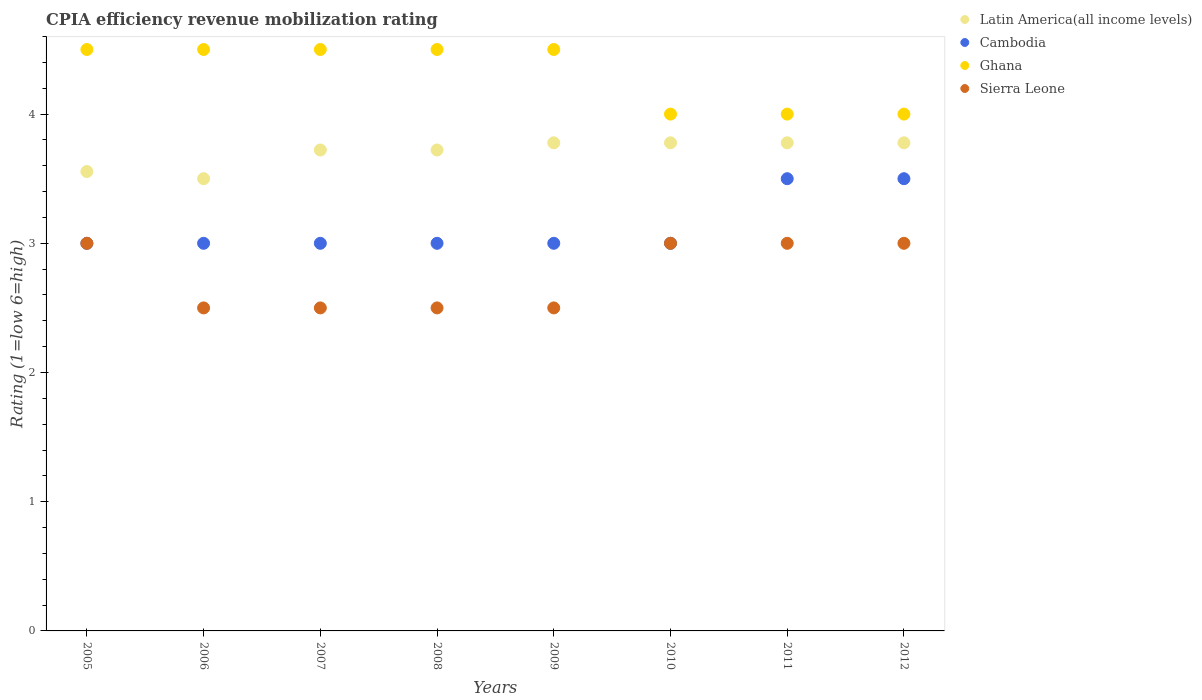Across all years, what is the minimum CPIA rating in Latin America(all income levels)?
Give a very brief answer. 3.5. What is the total CPIA rating in Latin America(all income levels) in the graph?
Offer a very short reply. 29.61. What is the difference between the CPIA rating in Latin America(all income levels) in 2005 and that in 2011?
Provide a short and direct response. -0.22. What is the difference between the CPIA rating in Latin America(all income levels) in 2009 and the CPIA rating in Ghana in 2010?
Offer a terse response. -0.22. What is the average CPIA rating in Latin America(all income levels) per year?
Provide a short and direct response. 3.7. In the year 2005, what is the difference between the CPIA rating in Ghana and CPIA rating in Latin America(all income levels)?
Your answer should be very brief. 0.94. What is the ratio of the CPIA rating in Cambodia in 2006 to that in 2012?
Provide a succinct answer. 0.86. Is the CPIA rating in Sierra Leone in 2007 less than that in 2009?
Offer a very short reply. No. What is the difference between the highest and the second highest CPIA rating in Cambodia?
Your response must be concise. 0. What is the difference between the highest and the lowest CPIA rating in Latin America(all income levels)?
Ensure brevity in your answer.  0.28. In how many years, is the CPIA rating in Ghana greater than the average CPIA rating in Ghana taken over all years?
Your answer should be compact. 5. Is it the case that in every year, the sum of the CPIA rating in Ghana and CPIA rating in Cambodia  is greater than the sum of CPIA rating in Latin America(all income levels) and CPIA rating in Sierra Leone?
Provide a succinct answer. No. Does the CPIA rating in Latin America(all income levels) monotonically increase over the years?
Your response must be concise. No. Is the CPIA rating in Cambodia strictly greater than the CPIA rating in Latin America(all income levels) over the years?
Make the answer very short. No. Is the CPIA rating in Ghana strictly less than the CPIA rating in Sierra Leone over the years?
Keep it short and to the point. No. How many years are there in the graph?
Your response must be concise. 8. Where does the legend appear in the graph?
Ensure brevity in your answer.  Top right. What is the title of the graph?
Provide a short and direct response. CPIA efficiency revenue mobilization rating. What is the label or title of the Y-axis?
Make the answer very short. Rating (1=low 6=high). What is the Rating (1=low 6=high) in Latin America(all income levels) in 2005?
Provide a short and direct response. 3.56. What is the Rating (1=low 6=high) in Ghana in 2006?
Offer a very short reply. 4.5. What is the Rating (1=low 6=high) of Sierra Leone in 2006?
Your answer should be very brief. 2.5. What is the Rating (1=low 6=high) of Latin America(all income levels) in 2007?
Offer a very short reply. 3.72. What is the Rating (1=low 6=high) of Cambodia in 2007?
Your response must be concise. 3. What is the Rating (1=low 6=high) of Ghana in 2007?
Give a very brief answer. 4.5. What is the Rating (1=low 6=high) of Latin America(all income levels) in 2008?
Make the answer very short. 3.72. What is the Rating (1=low 6=high) of Cambodia in 2008?
Offer a very short reply. 3. What is the Rating (1=low 6=high) in Ghana in 2008?
Your answer should be very brief. 4.5. What is the Rating (1=low 6=high) in Sierra Leone in 2008?
Your response must be concise. 2.5. What is the Rating (1=low 6=high) of Latin America(all income levels) in 2009?
Your answer should be very brief. 3.78. What is the Rating (1=low 6=high) in Latin America(all income levels) in 2010?
Make the answer very short. 3.78. What is the Rating (1=low 6=high) in Cambodia in 2010?
Give a very brief answer. 3. What is the Rating (1=low 6=high) in Latin America(all income levels) in 2011?
Make the answer very short. 3.78. What is the Rating (1=low 6=high) in Latin America(all income levels) in 2012?
Offer a terse response. 3.78. What is the Rating (1=low 6=high) of Cambodia in 2012?
Give a very brief answer. 3.5. What is the Rating (1=low 6=high) of Sierra Leone in 2012?
Give a very brief answer. 3. Across all years, what is the maximum Rating (1=low 6=high) of Latin America(all income levels)?
Provide a succinct answer. 3.78. Across all years, what is the maximum Rating (1=low 6=high) in Sierra Leone?
Give a very brief answer. 3. Across all years, what is the minimum Rating (1=low 6=high) in Cambodia?
Give a very brief answer. 3. Across all years, what is the minimum Rating (1=low 6=high) in Ghana?
Offer a terse response. 4. What is the total Rating (1=low 6=high) in Latin America(all income levels) in the graph?
Provide a short and direct response. 29.61. What is the total Rating (1=low 6=high) of Ghana in the graph?
Make the answer very short. 34.5. What is the difference between the Rating (1=low 6=high) of Latin America(all income levels) in 2005 and that in 2006?
Your answer should be compact. 0.06. What is the difference between the Rating (1=low 6=high) in Cambodia in 2005 and that in 2006?
Provide a short and direct response. 0. What is the difference between the Rating (1=low 6=high) of Ghana in 2005 and that in 2006?
Offer a terse response. 0. What is the difference between the Rating (1=low 6=high) of Sierra Leone in 2005 and that in 2006?
Provide a short and direct response. 0.5. What is the difference between the Rating (1=low 6=high) in Latin America(all income levels) in 2005 and that in 2007?
Your answer should be very brief. -0.17. What is the difference between the Rating (1=low 6=high) of Cambodia in 2005 and that in 2007?
Provide a short and direct response. 0. What is the difference between the Rating (1=low 6=high) of Latin America(all income levels) in 2005 and that in 2008?
Your answer should be compact. -0.17. What is the difference between the Rating (1=low 6=high) in Ghana in 2005 and that in 2008?
Your response must be concise. 0. What is the difference between the Rating (1=low 6=high) in Latin America(all income levels) in 2005 and that in 2009?
Your response must be concise. -0.22. What is the difference between the Rating (1=low 6=high) in Ghana in 2005 and that in 2009?
Provide a succinct answer. 0. What is the difference between the Rating (1=low 6=high) in Sierra Leone in 2005 and that in 2009?
Your response must be concise. 0.5. What is the difference between the Rating (1=low 6=high) of Latin America(all income levels) in 2005 and that in 2010?
Your answer should be compact. -0.22. What is the difference between the Rating (1=low 6=high) of Cambodia in 2005 and that in 2010?
Provide a short and direct response. 0. What is the difference between the Rating (1=low 6=high) in Ghana in 2005 and that in 2010?
Offer a very short reply. 0.5. What is the difference between the Rating (1=low 6=high) in Latin America(all income levels) in 2005 and that in 2011?
Give a very brief answer. -0.22. What is the difference between the Rating (1=low 6=high) of Ghana in 2005 and that in 2011?
Provide a short and direct response. 0.5. What is the difference between the Rating (1=low 6=high) in Sierra Leone in 2005 and that in 2011?
Provide a short and direct response. 0. What is the difference between the Rating (1=low 6=high) in Latin America(all income levels) in 2005 and that in 2012?
Provide a short and direct response. -0.22. What is the difference between the Rating (1=low 6=high) of Cambodia in 2005 and that in 2012?
Make the answer very short. -0.5. What is the difference between the Rating (1=low 6=high) in Ghana in 2005 and that in 2012?
Your response must be concise. 0.5. What is the difference between the Rating (1=low 6=high) of Latin America(all income levels) in 2006 and that in 2007?
Provide a short and direct response. -0.22. What is the difference between the Rating (1=low 6=high) of Sierra Leone in 2006 and that in 2007?
Your answer should be compact. 0. What is the difference between the Rating (1=low 6=high) of Latin America(all income levels) in 2006 and that in 2008?
Ensure brevity in your answer.  -0.22. What is the difference between the Rating (1=low 6=high) of Ghana in 2006 and that in 2008?
Your response must be concise. 0. What is the difference between the Rating (1=low 6=high) in Sierra Leone in 2006 and that in 2008?
Your answer should be compact. 0. What is the difference between the Rating (1=low 6=high) in Latin America(all income levels) in 2006 and that in 2009?
Your answer should be very brief. -0.28. What is the difference between the Rating (1=low 6=high) in Cambodia in 2006 and that in 2009?
Offer a very short reply. 0. What is the difference between the Rating (1=low 6=high) in Sierra Leone in 2006 and that in 2009?
Your answer should be compact. 0. What is the difference between the Rating (1=low 6=high) of Latin America(all income levels) in 2006 and that in 2010?
Your answer should be very brief. -0.28. What is the difference between the Rating (1=low 6=high) in Cambodia in 2006 and that in 2010?
Provide a succinct answer. 0. What is the difference between the Rating (1=low 6=high) of Latin America(all income levels) in 2006 and that in 2011?
Your response must be concise. -0.28. What is the difference between the Rating (1=low 6=high) in Cambodia in 2006 and that in 2011?
Your answer should be very brief. -0.5. What is the difference between the Rating (1=low 6=high) of Ghana in 2006 and that in 2011?
Your answer should be compact. 0.5. What is the difference between the Rating (1=low 6=high) of Sierra Leone in 2006 and that in 2011?
Offer a terse response. -0.5. What is the difference between the Rating (1=low 6=high) of Latin America(all income levels) in 2006 and that in 2012?
Your answer should be very brief. -0.28. What is the difference between the Rating (1=low 6=high) in Cambodia in 2006 and that in 2012?
Give a very brief answer. -0.5. What is the difference between the Rating (1=low 6=high) in Ghana in 2006 and that in 2012?
Make the answer very short. 0.5. What is the difference between the Rating (1=low 6=high) of Latin America(all income levels) in 2007 and that in 2008?
Your answer should be very brief. 0. What is the difference between the Rating (1=low 6=high) in Cambodia in 2007 and that in 2008?
Offer a very short reply. 0. What is the difference between the Rating (1=low 6=high) in Sierra Leone in 2007 and that in 2008?
Make the answer very short. 0. What is the difference between the Rating (1=low 6=high) of Latin America(all income levels) in 2007 and that in 2009?
Make the answer very short. -0.06. What is the difference between the Rating (1=low 6=high) in Sierra Leone in 2007 and that in 2009?
Offer a very short reply. 0. What is the difference between the Rating (1=low 6=high) in Latin America(all income levels) in 2007 and that in 2010?
Offer a terse response. -0.06. What is the difference between the Rating (1=low 6=high) in Latin America(all income levels) in 2007 and that in 2011?
Provide a short and direct response. -0.06. What is the difference between the Rating (1=low 6=high) in Cambodia in 2007 and that in 2011?
Ensure brevity in your answer.  -0.5. What is the difference between the Rating (1=low 6=high) of Latin America(all income levels) in 2007 and that in 2012?
Ensure brevity in your answer.  -0.06. What is the difference between the Rating (1=low 6=high) of Cambodia in 2007 and that in 2012?
Ensure brevity in your answer.  -0.5. What is the difference between the Rating (1=low 6=high) of Latin America(all income levels) in 2008 and that in 2009?
Provide a short and direct response. -0.06. What is the difference between the Rating (1=low 6=high) of Cambodia in 2008 and that in 2009?
Offer a terse response. 0. What is the difference between the Rating (1=low 6=high) of Ghana in 2008 and that in 2009?
Your answer should be compact. 0. What is the difference between the Rating (1=low 6=high) of Sierra Leone in 2008 and that in 2009?
Your answer should be compact. 0. What is the difference between the Rating (1=low 6=high) in Latin America(all income levels) in 2008 and that in 2010?
Your response must be concise. -0.06. What is the difference between the Rating (1=low 6=high) in Latin America(all income levels) in 2008 and that in 2011?
Give a very brief answer. -0.06. What is the difference between the Rating (1=low 6=high) in Cambodia in 2008 and that in 2011?
Your answer should be very brief. -0.5. What is the difference between the Rating (1=low 6=high) in Sierra Leone in 2008 and that in 2011?
Your response must be concise. -0.5. What is the difference between the Rating (1=low 6=high) of Latin America(all income levels) in 2008 and that in 2012?
Keep it short and to the point. -0.06. What is the difference between the Rating (1=low 6=high) of Cambodia in 2009 and that in 2010?
Your answer should be compact. 0. What is the difference between the Rating (1=low 6=high) of Ghana in 2009 and that in 2010?
Your response must be concise. 0.5. What is the difference between the Rating (1=low 6=high) in Sierra Leone in 2009 and that in 2010?
Keep it short and to the point. -0.5. What is the difference between the Rating (1=low 6=high) of Ghana in 2009 and that in 2011?
Provide a short and direct response. 0.5. What is the difference between the Rating (1=low 6=high) in Latin America(all income levels) in 2009 and that in 2012?
Provide a succinct answer. 0. What is the difference between the Rating (1=low 6=high) in Ghana in 2009 and that in 2012?
Your answer should be very brief. 0.5. What is the difference between the Rating (1=low 6=high) of Sierra Leone in 2009 and that in 2012?
Offer a terse response. -0.5. What is the difference between the Rating (1=low 6=high) of Latin America(all income levels) in 2010 and that in 2011?
Ensure brevity in your answer.  0. What is the difference between the Rating (1=low 6=high) of Ghana in 2010 and that in 2011?
Provide a short and direct response. 0. What is the difference between the Rating (1=low 6=high) in Sierra Leone in 2010 and that in 2011?
Your answer should be very brief. 0. What is the difference between the Rating (1=low 6=high) in Cambodia in 2010 and that in 2012?
Keep it short and to the point. -0.5. What is the difference between the Rating (1=low 6=high) of Sierra Leone in 2010 and that in 2012?
Provide a succinct answer. 0. What is the difference between the Rating (1=low 6=high) in Latin America(all income levels) in 2011 and that in 2012?
Offer a terse response. 0. What is the difference between the Rating (1=low 6=high) of Cambodia in 2011 and that in 2012?
Your response must be concise. 0. What is the difference between the Rating (1=low 6=high) in Latin America(all income levels) in 2005 and the Rating (1=low 6=high) in Cambodia in 2006?
Your answer should be very brief. 0.56. What is the difference between the Rating (1=low 6=high) of Latin America(all income levels) in 2005 and the Rating (1=low 6=high) of Ghana in 2006?
Your answer should be compact. -0.94. What is the difference between the Rating (1=low 6=high) in Latin America(all income levels) in 2005 and the Rating (1=low 6=high) in Sierra Leone in 2006?
Keep it short and to the point. 1.06. What is the difference between the Rating (1=low 6=high) in Latin America(all income levels) in 2005 and the Rating (1=low 6=high) in Cambodia in 2007?
Provide a short and direct response. 0.56. What is the difference between the Rating (1=low 6=high) of Latin America(all income levels) in 2005 and the Rating (1=low 6=high) of Ghana in 2007?
Provide a succinct answer. -0.94. What is the difference between the Rating (1=low 6=high) in Latin America(all income levels) in 2005 and the Rating (1=low 6=high) in Sierra Leone in 2007?
Your answer should be compact. 1.06. What is the difference between the Rating (1=low 6=high) of Cambodia in 2005 and the Rating (1=low 6=high) of Ghana in 2007?
Ensure brevity in your answer.  -1.5. What is the difference between the Rating (1=low 6=high) of Ghana in 2005 and the Rating (1=low 6=high) of Sierra Leone in 2007?
Offer a terse response. 2. What is the difference between the Rating (1=low 6=high) in Latin America(all income levels) in 2005 and the Rating (1=low 6=high) in Cambodia in 2008?
Make the answer very short. 0.56. What is the difference between the Rating (1=low 6=high) in Latin America(all income levels) in 2005 and the Rating (1=low 6=high) in Ghana in 2008?
Keep it short and to the point. -0.94. What is the difference between the Rating (1=low 6=high) of Latin America(all income levels) in 2005 and the Rating (1=low 6=high) of Sierra Leone in 2008?
Your answer should be very brief. 1.06. What is the difference between the Rating (1=low 6=high) of Cambodia in 2005 and the Rating (1=low 6=high) of Ghana in 2008?
Your answer should be very brief. -1.5. What is the difference between the Rating (1=low 6=high) in Cambodia in 2005 and the Rating (1=low 6=high) in Sierra Leone in 2008?
Provide a short and direct response. 0.5. What is the difference between the Rating (1=low 6=high) in Latin America(all income levels) in 2005 and the Rating (1=low 6=high) in Cambodia in 2009?
Keep it short and to the point. 0.56. What is the difference between the Rating (1=low 6=high) of Latin America(all income levels) in 2005 and the Rating (1=low 6=high) of Ghana in 2009?
Offer a very short reply. -0.94. What is the difference between the Rating (1=low 6=high) in Latin America(all income levels) in 2005 and the Rating (1=low 6=high) in Sierra Leone in 2009?
Keep it short and to the point. 1.06. What is the difference between the Rating (1=low 6=high) of Cambodia in 2005 and the Rating (1=low 6=high) of Sierra Leone in 2009?
Provide a short and direct response. 0.5. What is the difference between the Rating (1=low 6=high) in Latin America(all income levels) in 2005 and the Rating (1=low 6=high) in Cambodia in 2010?
Ensure brevity in your answer.  0.56. What is the difference between the Rating (1=low 6=high) in Latin America(all income levels) in 2005 and the Rating (1=low 6=high) in Ghana in 2010?
Make the answer very short. -0.44. What is the difference between the Rating (1=low 6=high) of Latin America(all income levels) in 2005 and the Rating (1=low 6=high) of Sierra Leone in 2010?
Your response must be concise. 0.56. What is the difference between the Rating (1=low 6=high) in Cambodia in 2005 and the Rating (1=low 6=high) in Ghana in 2010?
Provide a succinct answer. -1. What is the difference between the Rating (1=low 6=high) of Cambodia in 2005 and the Rating (1=low 6=high) of Sierra Leone in 2010?
Offer a terse response. 0. What is the difference between the Rating (1=low 6=high) of Ghana in 2005 and the Rating (1=low 6=high) of Sierra Leone in 2010?
Provide a succinct answer. 1.5. What is the difference between the Rating (1=low 6=high) in Latin America(all income levels) in 2005 and the Rating (1=low 6=high) in Cambodia in 2011?
Keep it short and to the point. 0.06. What is the difference between the Rating (1=low 6=high) of Latin America(all income levels) in 2005 and the Rating (1=low 6=high) of Ghana in 2011?
Ensure brevity in your answer.  -0.44. What is the difference between the Rating (1=low 6=high) in Latin America(all income levels) in 2005 and the Rating (1=low 6=high) in Sierra Leone in 2011?
Keep it short and to the point. 0.56. What is the difference between the Rating (1=low 6=high) in Cambodia in 2005 and the Rating (1=low 6=high) in Ghana in 2011?
Your response must be concise. -1. What is the difference between the Rating (1=low 6=high) in Latin America(all income levels) in 2005 and the Rating (1=low 6=high) in Cambodia in 2012?
Your response must be concise. 0.06. What is the difference between the Rating (1=low 6=high) in Latin America(all income levels) in 2005 and the Rating (1=low 6=high) in Ghana in 2012?
Provide a succinct answer. -0.44. What is the difference between the Rating (1=low 6=high) in Latin America(all income levels) in 2005 and the Rating (1=low 6=high) in Sierra Leone in 2012?
Provide a succinct answer. 0.56. What is the difference between the Rating (1=low 6=high) in Cambodia in 2005 and the Rating (1=low 6=high) in Ghana in 2012?
Ensure brevity in your answer.  -1. What is the difference between the Rating (1=low 6=high) in Ghana in 2005 and the Rating (1=low 6=high) in Sierra Leone in 2012?
Provide a short and direct response. 1.5. What is the difference between the Rating (1=low 6=high) of Latin America(all income levels) in 2006 and the Rating (1=low 6=high) of Cambodia in 2007?
Keep it short and to the point. 0.5. What is the difference between the Rating (1=low 6=high) in Latin America(all income levels) in 2006 and the Rating (1=low 6=high) in Ghana in 2007?
Your answer should be compact. -1. What is the difference between the Rating (1=low 6=high) in Latin America(all income levels) in 2006 and the Rating (1=low 6=high) in Sierra Leone in 2007?
Offer a very short reply. 1. What is the difference between the Rating (1=low 6=high) in Cambodia in 2006 and the Rating (1=low 6=high) in Sierra Leone in 2007?
Offer a very short reply. 0.5. What is the difference between the Rating (1=low 6=high) in Latin America(all income levels) in 2006 and the Rating (1=low 6=high) in Ghana in 2008?
Your response must be concise. -1. What is the difference between the Rating (1=low 6=high) of Latin America(all income levels) in 2006 and the Rating (1=low 6=high) of Sierra Leone in 2008?
Your response must be concise. 1. What is the difference between the Rating (1=low 6=high) of Cambodia in 2006 and the Rating (1=low 6=high) of Ghana in 2008?
Ensure brevity in your answer.  -1.5. What is the difference between the Rating (1=low 6=high) of Ghana in 2006 and the Rating (1=low 6=high) of Sierra Leone in 2008?
Your answer should be very brief. 2. What is the difference between the Rating (1=low 6=high) in Latin America(all income levels) in 2006 and the Rating (1=low 6=high) in Sierra Leone in 2009?
Provide a succinct answer. 1. What is the difference between the Rating (1=low 6=high) of Cambodia in 2006 and the Rating (1=low 6=high) of Ghana in 2009?
Provide a short and direct response. -1.5. What is the difference between the Rating (1=low 6=high) of Cambodia in 2006 and the Rating (1=low 6=high) of Sierra Leone in 2009?
Provide a short and direct response. 0.5. What is the difference between the Rating (1=low 6=high) of Latin America(all income levels) in 2006 and the Rating (1=low 6=high) of Cambodia in 2010?
Give a very brief answer. 0.5. What is the difference between the Rating (1=low 6=high) in Latin America(all income levels) in 2006 and the Rating (1=low 6=high) in Sierra Leone in 2010?
Provide a succinct answer. 0.5. What is the difference between the Rating (1=low 6=high) of Cambodia in 2006 and the Rating (1=low 6=high) of Ghana in 2010?
Ensure brevity in your answer.  -1. What is the difference between the Rating (1=low 6=high) in Ghana in 2006 and the Rating (1=low 6=high) in Sierra Leone in 2010?
Offer a terse response. 1.5. What is the difference between the Rating (1=low 6=high) of Latin America(all income levels) in 2006 and the Rating (1=low 6=high) of Cambodia in 2011?
Offer a terse response. 0. What is the difference between the Rating (1=low 6=high) in Cambodia in 2006 and the Rating (1=low 6=high) in Sierra Leone in 2011?
Your response must be concise. 0. What is the difference between the Rating (1=low 6=high) in Latin America(all income levels) in 2006 and the Rating (1=low 6=high) in Cambodia in 2012?
Your response must be concise. 0. What is the difference between the Rating (1=low 6=high) in Latin America(all income levels) in 2006 and the Rating (1=low 6=high) in Ghana in 2012?
Provide a short and direct response. -0.5. What is the difference between the Rating (1=low 6=high) in Latin America(all income levels) in 2006 and the Rating (1=low 6=high) in Sierra Leone in 2012?
Your answer should be very brief. 0.5. What is the difference between the Rating (1=low 6=high) in Cambodia in 2006 and the Rating (1=low 6=high) in Ghana in 2012?
Provide a succinct answer. -1. What is the difference between the Rating (1=low 6=high) of Cambodia in 2006 and the Rating (1=low 6=high) of Sierra Leone in 2012?
Provide a short and direct response. 0. What is the difference between the Rating (1=low 6=high) of Latin America(all income levels) in 2007 and the Rating (1=low 6=high) of Cambodia in 2008?
Your answer should be compact. 0.72. What is the difference between the Rating (1=low 6=high) in Latin America(all income levels) in 2007 and the Rating (1=low 6=high) in Ghana in 2008?
Provide a succinct answer. -0.78. What is the difference between the Rating (1=low 6=high) in Latin America(all income levels) in 2007 and the Rating (1=low 6=high) in Sierra Leone in 2008?
Provide a short and direct response. 1.22. What is the difference between the Rating (1=low 6=high) in Cambodia in 2007 and the Rating (1=low 6=high) in Ghana in 2008?
Your answer should be very brief. -1.5. What is the difference between the Rating (1=low 6=high) in Cambodia in 2007 and the Rating (1=low 6=high) in Sierra Leone in 2008?
Provide a succinct answer. 0.5. What is the difference between the Rating (1=low 6=high) of Latin America(all income levels) in 2007 and the Rating (1=low 6=high) of Cambodia in 2009?
Provide a short and direct response. 0.72. What is the difference between the Rating (1=low 6=high) of Latin America(all income levels) in 2007 and the Rating (1=low 6=high) of Ghana in 2009?
Provide a succinct answer. -0.78. What is the difference between the Rating (1=low 6=high) in Latin America(all income levels) in 2007 and the Rating (1=low 6=high) in Sierra Leone in 2009?
Provide a succinct answer. 1.22. What is the difference between the Rating (1=low 6=high) in Cambodia in 2007 and the Rating (1=low 6=high) in Sierra Leone in 2009?
Your response must be concise. 0.5. What is the difference between the Rating (1=low 6=high) in Latin America(all income levels) in 2007 and the Rating (1=low 6=high) in Cambodia in 2010?
Offer a terse response. 0.72. What is the difference between the Rating (1=low 6=high) in Latin America(all income levels) in 2007 and the Rating (1=low 6=high) in Ghana in 2010?
Offer a very short reply. -0.28. What is the difference between the Rating (1=low 6=high) of Latin America(all income levels) in 2007 and the Rating (1=low 6=high) of Sierra Leone in 2010?
Ensure brevity in your answer.  0.72. What is the difference between the Rating (1=low 6=high) in Ghana in 2007 and the Rating (1=low 6=high) in Sierra Leone in 2010?
Ensure brevity in your answer.  1.5. What is the difference between the Rating (1=low 6=high) in Latin America(all income levels) in 2007 and the Rating (1=low 6=high) in Cambodia in 2011?
Offer a very short reply. 0.22. What is the difference between the Rating (1=low 6=high) of Latin America(all income levels) in 2007 and the Rating (1=low 6=high) of Ghana in 2011?
Offer a terse response. -0.28. What is the difference between the Rating (1=low 6=high) of Latin America(all income levels) in 2007 and the Rating (1=low 6=high) of Sierra Leone in 2011?
Offer a very short reply. 0.72. What is the difference between the Rating (1=low 6=high) of Ghana in 2007 and the Rating (1=low 6=high) of Sierra Leone in 2011?
Offer a very short reply. 1.5. What is the difference between the Rating (1=low 6=high) of Latin America(all income levels) in 2007 and the Rating (1=low 6=high) of Cambodia in 2012?
Offer a very short reply. 0.22. What is the difference between the Rating (1=low 6=high) of Latin America(all income levels) in 2007 and the Rating (1=low 6=high) of Ghana in 2012?
Offer a very short reply. -0.28. What is the difference between the Rating (1=low 6=high) of Latin America(all income levels) in 2007 and the Rating (1=low 6=high) of Sierra Leone in 2012?
Offer a very short reply. 0.72. What is the difference between the Rating (1=low 6=high) of Cambodia in 2007 and the Rating (1=low 6=high) of Ghana in 2012?
Your response must be concise. -1. What is the difference between the Rating (1=low 6=high) in Latin America(all income levels) in 2008 and the Rating (1=low 6=high) in Cambodia in 2009?
Ensure brevity in your answer.  0.72. What is the difference between the Rating (1=low 6=high) in Latin America(all income levels) in 2008 and the Rating (1=low 6=high) in Ghana in 2009?
Keep it short and to the point. -0.78. What is the difference between the Rating (1=low 6=high) in Latin America(all income levels) in 2008 and the Rating (1=low 6=high) in Sierra Leone in 2009?
Your answer should be very brief. 1.22. What is the difference between the Rating (1=low 6=high) of Cambodia in 2008 and the Rating (1=low 6=high) of Ghana in 2009?
Provide a succinct answer. -1.5. What is the difference between the Rating (1=low 6=high) in Cambodia in 2008 and the Rating (1=low 6=high) in Sierra Leone in 2009?
Your answer should be very brief. 0.5. What is the difference between the Rating (1=low 6=high) in Ghana in 2008 and the Rating (1=low 6=high) in Sierra Leone in 2009?
Provide a succinct answer. 2. What is the difference between the Rating (1=low 6=high) in Latin America(all income levels) in 2008 and the Rating (1=low 6=high) in Cambodia in 2010?
Keep it short and to the point. 0.72. What is the difference between the Rating (1=low 6=high) in Latin America(all income levels) in 2008 and the Rating (1=low 6=high) in Ghana in 2010?
Keep it short and to the point. -0.28. What is the difference between the Rating (1=low 6=high) in Latin America(all income levels) in 2008 and the Rating (1=low 6=high) in Sierra Leone in 2010?
Your response must be concise. 0.72. What is the difference between the Rating (1=low 6=high) of Cambodia in 2008 and the Rating (1=low 6=high) of Ghana in 2010?
Provide a short and direct response. -1. What is the difference between the Rating (1=low 6=high) of Cambodia in 2008 and the Rating (1=low 6=high) of Sierra Leone in 2010?
Provide a short and direct response. 0. What is the difference between the Rating (1=low 6=high) in Ghana in 2008 and the Rating (1=low 6=high) in Sierra Leone in 2010?
Provide a short and direct response. 1.5. What is the difference between the Rating (1=low 6=high) in Latin America(all income levels) in 2008 and the Rating (1=low 6=high) in Cambodia in 2011?
Provide a succinct answer. 0.22. What is the difference between the Rating (1=low 6=high) in Latin America(all income levels) in 2008 and the Rating (1=low 6=high) in Ghana in 2011?
Ensure brevity in your answer.  -0.28. What is the difference between the Rating (1=low 6=high) in Latin America(all income levels) in 2008 and the Rating (1=low 6=high) in Sierra Leone in 2011?
Make the answer very short. 0.72. What is the difference between the Rating (1=low 6=high) in Cambodia in 2008 and the Rating (1=low 6=high) in Ghana in 2011?
Your response must be concise. -1. What is the difference between the Rating (1=low 6=high) of Latin America(all income levels) in 2008 and the Rating (1=low 6=high) of Cambodia in 2012?
Provide a short and direct response. 0.22. What is the difference between the Rating (1=low 6=high) in Latin America(all income levels) in 2008 and the Rating (1=low 6=high) in Ghana in 2012?
Provide a short and direct response. -0.28. What is the difference between the Rating (1=low 6=high) in Latin America(all income levels) in 2008 and the Rating (1=low 6=high) in Sierra Leone in 2012?
Give a very brief answer. 0.72. What is the difference between the Rating (1=low 6=high) of Cambodia in 2008 and the Rating (1=low 6=high) of Ghana in 2012?
Your answer should be compact. -1. What is the difference between the Rating (1=low 6=high) of Ghana in 2008 and the Rating (1=low 6=high) of Sierra Leone in 2012?
Provide a short and direct response. 1.5. What is the difference between the Rating (1=low 6=high) in Latin America(all income levels) in 2009 and the Rating (1=low 6=high) in Ghana in 2010?
Provide a short and direct response. -0.22. What is the difference between the Rating (1=low 6=high) of Latin America(all income levels) in 2009 and the Rating (1=low 6=high) of Sierra Leone in 2010?
Your answer should be compact. 0.78. What is the difference between the Rating (1=low 6=high) in Cambodia in 2009 and the Rating (1=low 6=high) in Ghana in 2010?
Provide a short and direct response. -1. What is the difference between the Rating (1=low 6=high) in Latin America(all income levels) in 2009 and the Rating (1=low 6=high) in Cambodia in 2011?
Offer a terse response. 0.28. What is the difference between the Rating (1=low 6=high) of Latin America(all income levels) in 2009 and the Rating (1=low 6=high) of Ghana in 2011?
Your response must be concise. -0.22. What is the difference between the Rating (1=low 6=high) of Latin America(all income levels) in 2009 and the Rating (1=low 6=high) of Cambodia in 2012?
Give a very brief answer. 0.28. What is the difference between the Rating (1=low 6=high) in Latin America(all income levels) in 2009 and the Rating (1=low 6=high) in Ghana in 2012?
Your response must be concise. -0.22. What is the difference between the Rating (1=low 6=high) in Latin America(all income levels) in 2009 and the Rating (1=low 6=high) in Sierra Leone in 2012?
Provide a succinct answer. 0.78. What is the difference between the Rating (1=low 6=high) of Cambodia in 2009 and the Rating (1=low 6=high) of Sierra Leone in 2012?
Provide a short and direct response. 0. What is the difference between the Rating (1=low 6=high) of Ghana in 2009 and the Rating (1=low 6=high) of Sierra Leone in 2012?
Offer a terse response. 1.5. What is the difference between the Rating (1=low 6=high) of Latin America(all income levels) in 2010 and the Rating (1=low 6=high) of Cambodia in 2011?
Offer a very short reply. 0.28. What is the difference between the Rating (1=low 6=high) in Latin America(all income levels) in 2010 and the Rating (1=low 6=high) in Ghana in 2011?
Offer a terse response. -0.22. What is the difference between the Rating (1=low 6=high) in Cambodia in 2010 and the Rating (1=low 6=high) in Sierra Leone in 2011?
Offer a terse response. 0. What is the difference between the Rating (1=low 6=high) in Latin America(all income levels) in 2010 and the Rating (1=low 6=high) in Cambodia in 2012?
Offer a very short reply. 0.28. What is the difference between the Rating (1=low 6=high) of Latin America(all income levels) in 2010 and the Rating (1=low 6=high) of Ghana in 2012?
Ensure brevity in your answer.  -0.22. What is the difference between the Rating (1=low 6=high) of Latin America(all income levels) in 2011 and the Rating (1=low 6=high) of Cambodia in 2012?
Ensure brevity in your answer.  0.28. What is the difference between the Rating (1=low 6=high) of Latin America(all income levels) in 2011 and the Rating (1=low 6=high) of Ghana in 2012?
Keep it short and to the point. -0.22. What is the difference between the Rating (1=low 6=high) of Cambodia in 2011 and the Rating (1=low 6=high) of Ghana in 2012?
Offer a terse response. -0.5. What is the difference between the Rating (1=low 6=high) in Cambodia in 2011 and the Rating (1=low 6=high) in Sierra Leone in 2012?
Offer a very short reply. 0.5. What is the average Rating (1=low 6=high) of Latin America(all income levels) per year?
Offer a very short reply. 3.7. What is the average Rating (1=low 6=high) in Cambodia per year?
Offer a terse response. 3.12. What is the average Rating (1=low 6=high) of Ghana per year?
Keep it short and to the point. 4.31. What is the average Rating (1=low 6=high) in Sierra Leone per year?
Offer a terse response. 2.75. In the year 2005, what is the difference between the Rating (1=low 6=high) of Latin America(all income levels) and Rating (1=low 6=high) of Cambodia?
Keep it short and to the point. 0.56. In the year 2005, what is the difference between the Rating (1=low 6=high) in Latin America(all income levels) and Rating (1=low 6=high) in Ghana?
Your answer should be compact. -0.94. In the year 2005, what is the difference between the Rating (1=low 6=high) of Latin America(all income levels) and Rating (1=low 6=high) of Sierra Leone?
Keep it short and to the point. 0.56. In the year 2005, what is the difference between the Rating (1=low 6=high) of Cambodia and Rating (1=low 6=high) of Ghana?
Your answer should be compact. -1.5. In the year 2005, what is the difference between the Rating (1=low 6=high) of Ghana and Rating (1=low 6=high) of Sierra Leone?
Make the answer very short. 1.5. In the year 2006, what is the difference between the Rating (1=low 6=high) in Latin America(all income levels) and Rating (1=low 6=high) in Ghana?
Your response must be concise. -1. In the year 2006, what is the difference between the Rating (1=low 6=high) in Cambodia and Rating (1=low 6=high) in Ghana?
Provide a short and direct response. -1.5. In the year 2006, what is the difference between the Rating (1=low 6=high) in Cambodia and Rating (1=low 6=high) in Sierra Leone?
Your answer should be very brief. 0.5. In the year 2006, what is the difference between the Rating (1=low 6=high) of Ghana and Rating (1=low 6=high) of Sierra Leone?
Provide a short and direct response. 2. In the year 2007, what is the difference between the Rating (1=low 6=high) in Latin America(all income levels) and Rating (1=low 6=high) in Cambodia?
Keep it short and to the point. 0.72. In the year 2007, what is the difference between the Rating (1=low 6=high) of Latin America(all income levels) and Rating (1=low 6=high) of Ghana?
Keep it short and to the point. -0.78. In the year 2007, what is the difference between the Rating (1=low 6=high) of Latin America(all income levels) and Rating (1=low 6=high) of Sierra Leone?
Provide a short and direct response. 1.22. In the year 2007, what is the difference between the Rating (1=low 6=high) of Cambodia and Rating (1=low 6=high) of Ghana?
Give a very brief answer. -1.5. In the year 2007, what is the difference between the Rating (1=low 6=high) in Cambodia and Rating (1=low 6=high) in Sierra Leone?
Your answer should be very brief. 0.5. In the year 2008, what is the difference between the Rating (1=low 6=high) in Latin America(all income levels) and Rating (1=low 6=high) in Cambodia?
Give a very brief answer. 0.72. In the year 2008, what is the difference between the Rating (1=low 6=high) of Latin America(all income levels) and Rating (1=low 6=high) of Ghana?
Provide a succinct answer. -0.78. In the year 2008, what is the difference between the Rating (1=low 6=high) in Latin America(all income levels) and Rating (1=low 6=high) in Sierra Leone?
Provide a succinct answer. 1.22. In the year 2008, what is the difference between the Rating (1=low 6=high) of Cambodia and Rating (1=low 6=high) of Ghana?
Keep it short and to the point. -1.5. In the year 2008, what is the difference between the Rating (1=low 6=high) of Ghana and Rating (1=low 6=high) of Sierra Leone?
Offer a very short reply. 2. In the year 2009, what is the difference between the Rating (1=low 6=high) of Latin America(all income levels) and Rating (1=low 6=high) of Ghana?
Your response must be concise. -0.72. In the year 2009, what is the difference between the Rating (1=low 6=high) of Latin America(all income levels) and Rating (1=low 6=high) of Sierra Leone?
Your answer should be compact. 1.28. In the year 2010, what is the difference between the Rating (1=low 6=high) of Latin America(all income levels) and Rating (1=low 6=high) of Cambodia?
Make the answer very short. 0.78. In the year 2010, what is the difference between the Rating (1=low 6=high) of Latin America(all income levels) and Rating (1=low 6=high) of Ghana?
Your answer should be very brief. -0.22. In the year 2010, what is the difference between the Rating (1=low 6=high) in Cambodia and Rating (1=low 6=high) in Sierra Leone?
Make the answer very short. 0. In the year 2011, what is the difference between the Rating (1=low 6=high) in Latin America(all income levels) and Rating (1=low 6=high) in Cambodia?
Keep it short and to the point. 0.28. In the year 2011, what is the difference between the Rating (1=low 6=high) in Latin America(all income levels) and Rating (1=low 6=high) in Ghana?
Offer a terse response. -0.22. In the year 2011, what is the difference between the Rating (1=low 6=high) in Cambodia and Rating (1=low 6=high) in Ghana?
Your answer should be compact. -0.5. In the year 2012, what is the difference between the Rating (1=low 6=high) of Latin America(all income levels) and Rating (1=low 6=high) of Cambodia?
Ensure brevity in your answer.  0.28. In the year 2012, what is the difference between the Rating (1=low 6=high) of Latin America(all income levels) and Rating (1=low 6=high) of Ghana?
Your answer should be compact. -0.22. In the year 2012, what is the difference between the Rating (1=low 6=high) in Latin America(all income levels) and Rating (1=low 6=high) in Sierra Leone?
Your answer should be compact. 0.78. In the year 2012, what is the difference between the Rating (1=low 6=high) in Cambodia and Rating (1=low 6=high) in Sierra Leone?
Provide a succinct answer. 0.5. What is the ratio of the Rating (1=low 6=high) in Latin America(all income levels) in 2005 to that in 2006?
Your answer should be compact. 1.02. What is the ratio of the Rating (1=low 6=high) of Latin America(all income levels) in 2005 to that in 2007?
Make the answer very short. 0.96. What is the ratio of the Rating (1=low 6=high) in Ghana in 2005 to that in 2007?
Your answer should be compact. 1. What is the ratio of the Rating (1=low 6=high) in Latin America(all income levels) in 2005 to that in 2008?
Keep it short and to the point. 0.96. What is the ratio of the Rating (1=low 6=high) in Ghana in 2005 to that in 2008?
Provide a succinct answer. 1. What is the ratio of the Rating (1=low 6=high) of Sierra Leone in 2005 to that in 2009?
Your response must be concise. 1.2. What is the ratio of the Rating (1=low 6=high) of Cambodia in 2005 to that in 2010?
Your response must be concise. 1. What is the ratio of the Rating (1=low 6=high) in Ghana in 2005 to that in 2010?
Make the answer very short. 1.12. What is the ratio of the Rating (1=low 6=high) in Latin America(all income levels) in 2005 to that in 2011?
Your response must be concise. 0.94. What is the ratio of the Rating (1=low 6=high) in Cambodia in 2005 to that in 2011?
Ensure brevity in your answer.  0.86. What is the ratio of the Rating (1=low 6=high) of Ghana in 2005 to that in 2011?
Offer a very short reply. 1.12. What is the ratio of the Rating (1=low 6=high) in Sierra Leone in 2005 to that in 2012?
Keep it short and to the point. 1. What is the ratio of the Rating (1=low 6=high) in Latin America(all income levels) in 2006 to that in 2007?
Offer a very short reply. 0.94. What is the ratio of the Rating (1=low 6=high) in Ghana in 2006 to that in 2007?
Give a very brief answer. 1. What is the ratio of the Rating (1=low 6=high) of Latin America(all income levels) in 2006 to that in 2008?
Give a very brief answer. 0.94. What is the ratio of the Rating (1=low 6=high) in Ghana in 2006 to that in 2008?
Offer a very short reply. 1. What is the ratio of the Rating (1=low 6=high) of Latin America(all income levels) in 2006 to that in 2009?
Give a very brief answer. 0.93. What is the ratio of the Rating (1=low 6=high) in Ghana in 2006 to that in 2009?
Offer a terse response. 1. What is the ratio of the Rating (1=low 6=high) in Latin America(all income levels) in 2006 to that in 2010?
Ensure brevity in your answer.  0.93. What is the ratio of the Rating (1=low 6=high) of Cambodia in 2006 to that in 2010?
Keep it short and to the point. 1. What is the ratio of the Rating (1=low 6=high) in Ghana in 2006 to that in 2010?
Provide a succinct answer. 1.12. What is the ratio of the Rating (1=low 6=high) in Sierra Leone in 2006 to that in 2010?
Provide a short and direct response. 0.83. What is the ratio of the Rating (1=low 6=high) of Latin America(all income levels) in 2006 to that in 2011?
Ensure brevity in your answer.  0.93. What is the ratio of the Rating (1=low 6=high) of Cambodia in 2006 to that in 2011?
Make the answer very short. 0.86. What is the ratio of the Rating (1=low 6=high) in Latin America(all income levels) in 2006 to that in 2012?
Your answer should be very brief. 0.93. What is the ratio of the Rating (1=low 6=high) in Cambodia in 2006 to that in 2012?
Offer a terse response. 0.86. What is the ratio of the Rating (1=low 6=high) of Ghana in 2006 to that in 2012?
Your answer should be compact. 1.12. What is the ratio of the Rating (1=low 6=high) in Sierra Leone in 2006 to that in 2012?
Offer a terse response. 0.83. What is the ratio of the Rating (1=low 6=high) of Latin America(all income levels) in 2007 to that in 2008?
Your response must be concise. 1. What is the ratio of the Rating (1=low 6=high) in Cambodia in 2007 to that in 2008?
Your answer should be compact. 1. What is the ratio of the Rating (1=low 6=high) of Sierra Leone in 2007 to that in 2008?
Offer a very short reply. 1. What is the ratio of the Rating (1=low 6=high) of Latin America(all income levels) in 2007 to that in 2009?
Your answer should be compact. 0.99. What is the ratio of the Rating (1=low 6=high) of Cambodia in 2007 to that in 2009?
Your response must be concise. 1. What is the ratio of the Rating (1=low 6=high) of Sierra Leone in 2007 to that in 2009?
Your answer should be very brief. 1. What is the ratio of the Rating (1=low 6=high) in Cambodia in 2007 to that in 2010?
Ensure brevity in your answer.  1. What is the ratio of the Rating (1=low 6=high) in Sierra Leone in 2007 to that in 2010?
Offer a terse response. 0.83. What is the ratio of the Rating (1=low 6=high) in Cambodia in 2007 to that in 2011?
Keep it short and to the point. 0.86. What is the ratio of the Rating (1=low 6=high) in Ghana in 2007 to that in 2012?
Offer a terse response. 1.12. What is the ratio of the Rating (1=low 6=high) of Ghana in 2008 to that in 2009?
Make the answer very short. 1. What is the ratio of the Rating (1=low 6=high) of Sierra Leone in 2008 to that in 2009?
Ensure brevity in your answer.  1. What is the ratio of the Rating (1=low 6=high) of Latin America(all income levels) in 2008 to that in 2010?
Keep it short and to the point. 0.99. What is the ratio of the Rating (1=low 6=high) in Ghana in 2008 to that in 2010?
Provide a succinct answer. 1.12. What is the ratio of the Rating (1=low 6=high) of Sierra Leone in 2008 to that in 2010?
Provide a short and direct response. 0.83. What is the ratio of the Rating (1=low 6=high) in Cambodia in 2008 to that in 2011?
Keep it short and to the point. 0.86. What is the ratio of the Rating (1=low 6=high) of Cambodia in 2008 to that in 2012?
Provide a succinct answer. 0.86. What is the ratio of the Rating (1=low 6=high) in Sierra Leone in 2008 to that in 2012?
Your response must be concise. 0.83. What is the ratio of the Rating (1=low 6=high) of Latin America(all income levels) in 2009 to that in 2010?
Offer a very short reply. 1. What is the ratio of the Rating (1=low 6=high) of Cambodia in 2009 to that in 2010?
Keep it short and to the point. 1. What is the ratio of the Rating (1=low 6=high) of Sierra Leone in 2009 to that in 2010?
Make the answer very short. 0.83. What is the ratio of the Rating (1=low 6=high) in Cambodia in 2009 to that in 2011?
Your answer should be compact. 0.86. What is the ratio of the Rating (1=low 6=high) of Ghana in 2009 to that in 2011?
Your answer should be compact. 1.12. What is the ratio of the Rating (1=low 6=high) in Sierra Leone in 2009 to that in 2011?
Give a very brief answer. 0.83. What is the ratio of the Rating (1=low 6=high) in Latin America(all income levels) in 2010 to that in 2011?
Provide a succinct answer. 1. What is the ratio of the Rating (1=low 6=high) in Latin America(all income levels) in 2010 to that in 2012?
Keep it short and to the point. 1. What is the ratio of the Rating (1=low 6=high) in Cambodia in 2010 to that in 2012?
Your response must be concise. 0.86. What is the ratio of the Rating (1=low 6=high) in Latin America(all income levels) in 2011 to that in 2012?
Provide a short and direct response. 1. What is the ratio of the Rating (1=low 6=high) of Ghana in 2011 to that in 2012?
Offer a very short reply. 1. What is the ratio of the Rating (1=low 6=high) in Sierra Leone in 2011 to that in 2012?
Your answer should be compact. 1. What is the difference between the highest and the second highest Rating (1=low 6=high) in Latin America(all income levels)?
Offer a very short reply. 0. What is the difference between the highest and the second highest Rating (1=low 6=high) of Cambodia?
Your answer should be compact. 0. What is the difference between the highest and the second highest Rating (1=low 6=high) in Ghana?
Keep it short and to the point. 0. What is the difference between the highest and the lowest Rating (1=low 6=high) in Latin America(all income levels)?
Provide a succinct answer. 0.28. What is the difference between the highest and the lowest Rating (1=low 6=high) in Ghana?
Your response must be concise. 0.5. What is the difference between the highest and the lowest Rating (1=low 6=high) of Sierra Leone?
Your answer should be compact. 0.5. 